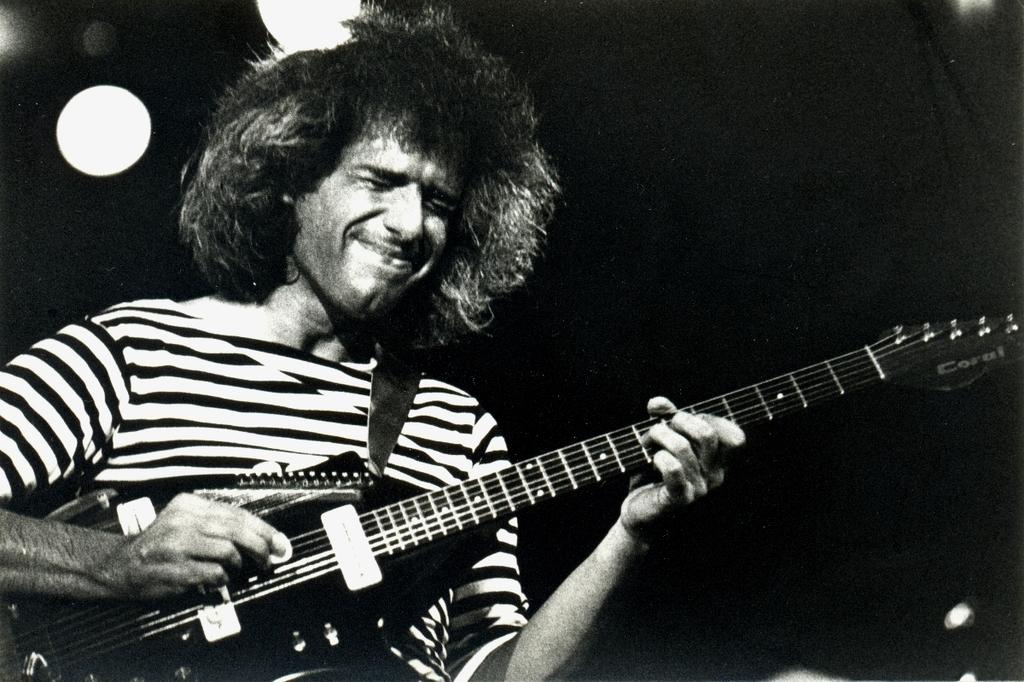What is the color scheme of the picture? The picture is black and white. How would you describe the background of the image? The background of the picture is dark. Can you identify any person in the image? Yes, there is a man in the picture. What is the man wearing in the image? The man is wearing a t-shirt. What activity is the man engaged in? The man is playing a guitar. What type of government is depicted in the image? There is no depiction of a government in the image; it features a man playing a guitar. What kind of vessel is being used by the man in the image? There is no vessel present in the image; the man is playing a guitar. 